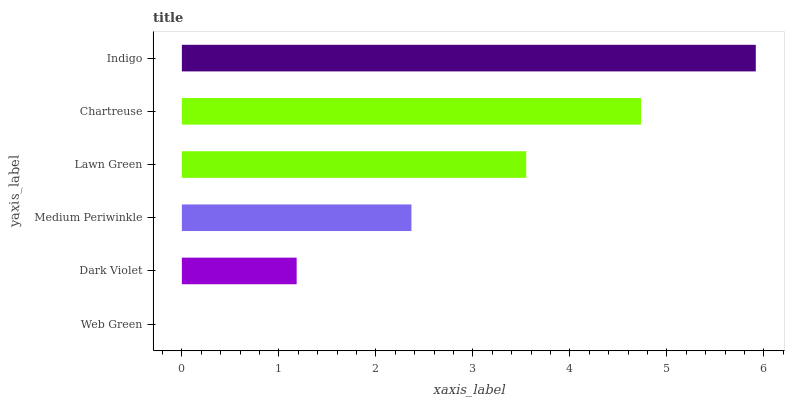Is Web Green the minimum?
Answer yes or no. Yes. Is Indigo the maximum?
Answer yes or no. Yes. Is Dark Violet the minimum?
Answer yes or no. No. Is Dark Violet the maximum?
Answer yes or no. No. Is Dark Violet greater than Web Green?
Answer yes or no. Yes. Is Web Green less than Dark Violet?
Answer yes or no. Yes. Is Web Green greater than Dark Violet?
Answer yes or no. No. Is Dark Violet less than Web Green?
Answer yes or no. No. Is Lawn Green the high median?
Answer yes or no. Yes. Is Medium Periwinkle the low median?
Answer yes or no. Yes. Is Chartreuse the high median?
Answer yes or no. No. Is Web Green the low median?
Answer yes or no. No. 